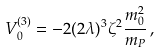<formula> <loc_0><loc_0><loc_500><loc_500>V ^ { ( 3 ) } _ { 0 } = - 2 ( 2 \lambda ) ^ { 3 } \zeta ^ { 2 } \frac { m _ { 0 } ^ { 2 } } { m _ { P } } \, ,</formula> 